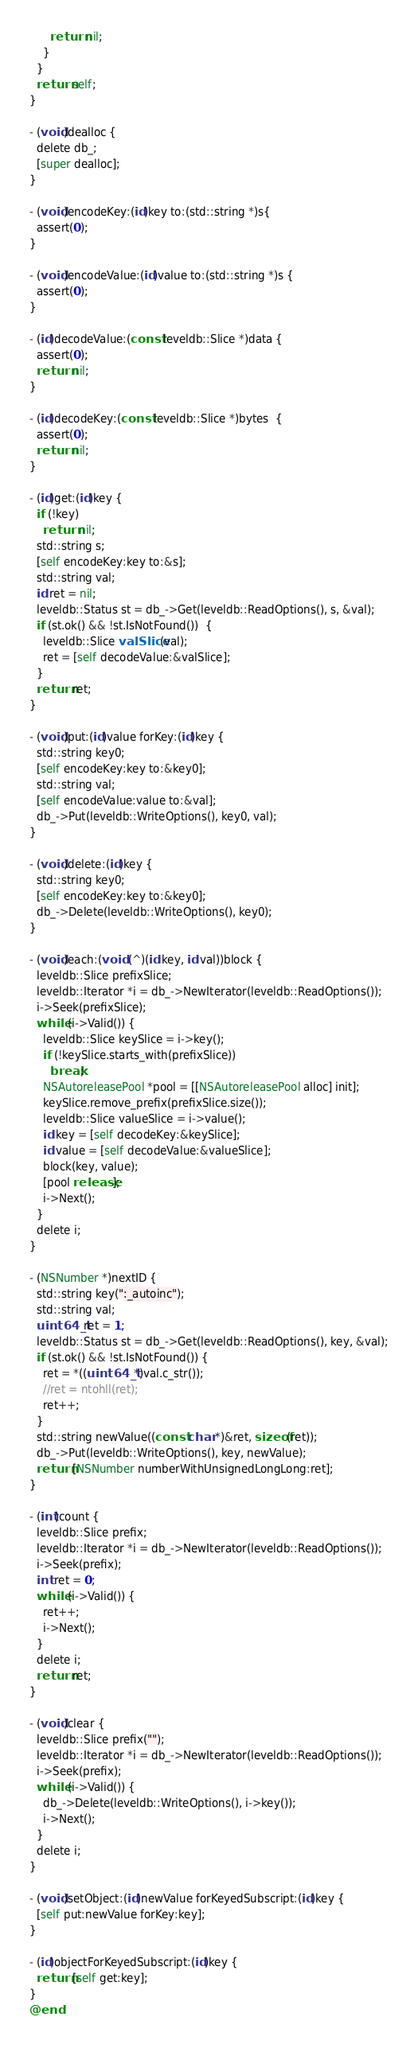<code> <loc_0><loc_0><loc_500><loc_500><_ObjectiveC_>      return nil;
    }
  }
  return self;
}

- (void)dealloc {
  delete db_;
  [super dealloc];
}

- (void)encodeKey:(id)key to:(std::string *)s{
  assert(0);
}

- (void)encodeValue:(id)value to:(std::string *)s {
  assert(0);
}

- (id)decodeValue:(const leveldb::Slice *)data {
  assert(0);
  return nil;
}

- (id)decodeKey:(const leveldb::Slice *)bytes  {
  assert(0);
  return nil;
}

- (id)get:(id)key {
  if (!key)
    return nil;
  std::string s;
  [self encodeKey:key to:&s];
  std::string val;
  id ret = nil;
  leveldb::Status st = db_->Get(leveldb::ReadOptions(), s, &val);
  if (st.ok() && !st.IsNotFound())  {
    leveldb::Slice valSlice(val);
    ret = [self decodeValue:&valSlice];
  }
  return ret;
}

- (void)put:(id)value forKey:(id)key {
  std::string key0;
  [self encodeKey:key to:&key0];
  std::string val;
  [self encodeValue:value to:&val];
  db_->Put(leveldb::WriteOptions(), key0, val);
}

- (void)delete:(id)key {
  std::string key0;
  [self encodeKey:key to:&key0];
  db_->Delete(leveldb::WriteOptions(), key0);
}

- (void)each:(void (^)(id key, id val))block {
  leveldb::Slice prefixSlice;
  leveldb::Iterator *i = db_->NewIterator(leveldb::ReadOptions());
  i->Seek(prefixSlice);
  while (i->Valid()) {
    leveldb::Slice keySlice = i->key();
    if (!keySlice.starts_with(prefixSlice))
      break;
    NSAutoreleasePool *pool = [[NSAutoreleasePool alloc] init];
    keySlice.remove_prefix(prefixSlice.size());
    leveldb::Slice valueSlice = i->value();
    id key = [self decodeKey:&keySlice];
    id value = [self decodeValue:&valueSlice];
    block(key, value);
    [pool release];
    i->Next();
  }
  delete i;
}

- (NSNumber *)nextID {
  std::string key(":_autoinc");
  std::string val;
  uint64_t ret = 1;
  leveldb::Status st = db_->Get(leveldb::ReadOptions(), key, &val);
  if (st.ok() && !st.IsNotFound()) {
    ret = *((uint64_t *)val.c_str());
    //ret = ntohll(ret);
    ret++;
  }
  std::string newValue((const char *)&ret, sizeof(ret));
  db_->Put(leveldb::WriteOptions(), key, newValue);
  return [NSNumber numberWithUnsignedLongLong:ret];
}

- (int)count {
  leveldb::Slice prefix;
  leveldb::Iterator *i = db_->NewIterator(leveldb::ReadOptions());
  i->Seek(prefix);
  int ret = 0;
  while (i->Valid()) {
    ret++;
    i->Next();
  }
  delete i;
  return ret;
}

- (void)clear {
  leveldb::Slice prefix("");
  leveldb::Iterator *i = db_->NewIterator(leveldb::ReadOptions());
  i->Seek(prefix);
  while (i->Valid()) {
    db_->Delete(leveldb::WriteOptions(), i->key());
    i->Next();
  }
  delete i;
}

- (void)setObject:(id)newValue forKeyedSubscript:(id)key {
  [self put:newValue forKey:key];
}

- (id)objectForKeyedSubscript:(id)key {
  return [self get:key];
}
@end

</code> 